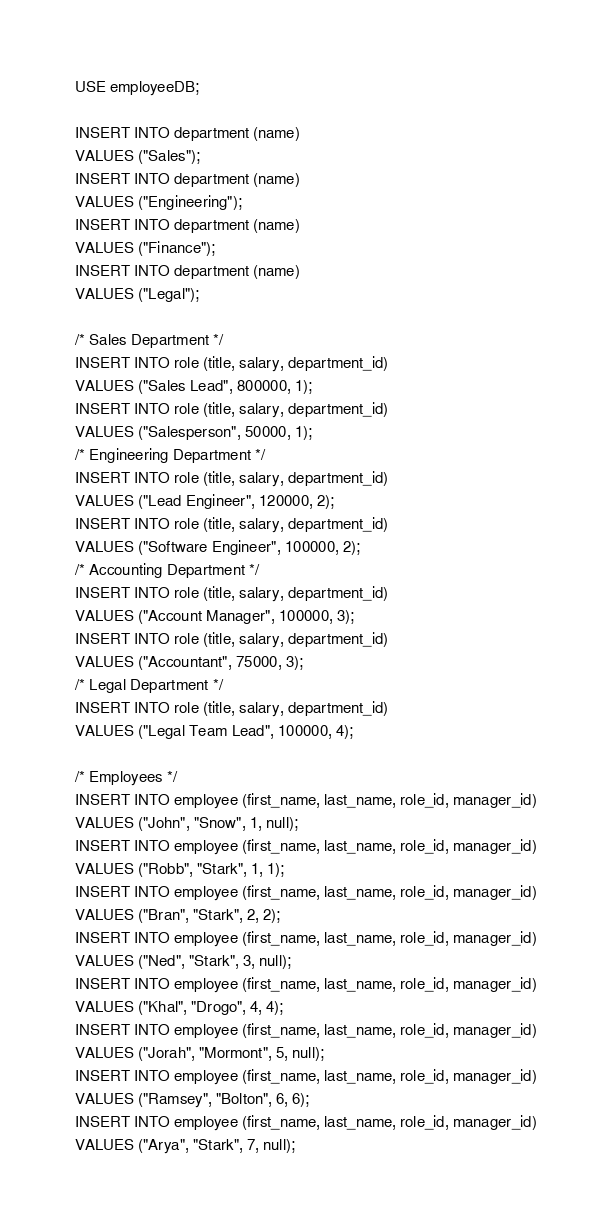Convert code to text. <code><loc_0><loc_0><loc_500><loc_500><_SQL_>USE employeeDB;

INSERT INTO department (name)
VALUES ("Sales");
INSERT INTO department (name)
VALUES ("Engineering");
INSERT INTO department (name)
VALUES ("Finance");
INSERT INTO department (name)
VALUES ("Legal");

/* Sales Department */
INSERT INTO role (title, salary, department_id)
VALUES ("Sales Lead", 800000, 1);
INSERT INTO role (title, salary, department_id)
VALUES ("Salesperson", 50000, 1);
/* Engineering Department */
INSERT INTO role (title, salary, department_id)
VALUES ("Lead Engineer", 120000, 2);
INSERT INTO role (title, salary, department_id)
VALUES ("Software Engineer", 100000, 2);
/* Accounting Department */
INSERT INTO role (title, salary, department_id)
VALUES ("Account Manager", 100000, 3);
INSERT INTO role (title, salary, department_id)
VALUES ("Accountant", 75000, 3);
/* Legal Department */
INSERT INTO role (title, salary, department_id)
VALUES ("Legal Team Lead", 100000, 4);

/* Employees */
INSERT INTO employee (first_name, last_name, role_id, manager_id)
VALUES ("John", "Snow", 1, null); 
INSERT INTO employee (first_name, last_name, role_id, manager_id)
VALUES ("Robb", "Stark", 1, 1);
INSERT INTO employee (first_name, last_name, role_id, manager_id)
VALUES ("Bran", "Stark", 2, 2);
INSERT INTO employee (first_name, last_name, role_id, manager_id)
VALUES ("Ned", "Stark", 3, null);
INSERT INTO employee (first_name, last_name, role_id, manager_id)
VALUES ("Khal", "Drogo", 4, 4);
INSERT INTO employee (first_name, last_name, role_id, manager_id)
VALUES ("Jorah", "Mormont", 5, null);
INSERT INTO employee (first_name, last_name, role_id, manager_id)
VALUES ("Ramsey", "Bolton", 6, 6);
INSERT INTO employee (first_name, last_name, role_id, manager_id)
VALUES ("Arya", "Stark", 7, null);</code> 